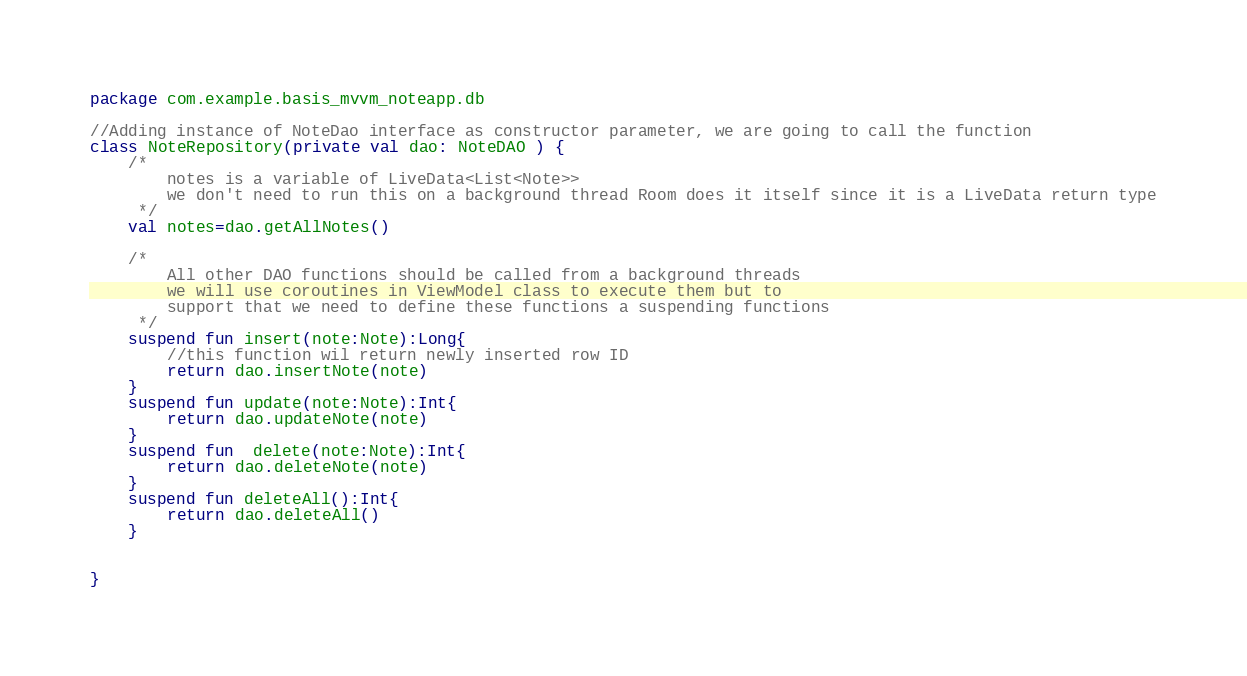Convert code to text. <code><loc_0><loc_0><loc_500><loc_500><_Kotlin_>package com.example.basis_mvvm_noteapp.db

//Adding instance of NoteDao interface as constructor parameter, we are going to call the function
class NoteRepository(private val dao: NoteDAO ) {
    /*
        notes is a variable of LiveData<List<Note>>
        we don't need to run this on a background thread Room does it itself since it is a LiveData return type
     */
    val notes=dao.getAllNotes()

    /*
        All other DAO functions should be called from a background threads
        we will use coroutines in ViewModel class to execute them but to
        support that we need to define these functions a suspending functions
     */
    suspend fun insert(note:Note):Long{
        //this function wil return newly inserted row ID
        return dao.insertNote(note)
    }
    suspend fun update(note:Note):Int{
        return dao.updateNote(note)
    }
    suspend fun  delete(note:Note):Int{
        return dao.deleteNote(note)
    }
    suspend fun deleteAll():Int{
        return dao.deleteAll()
    }


}</code> 